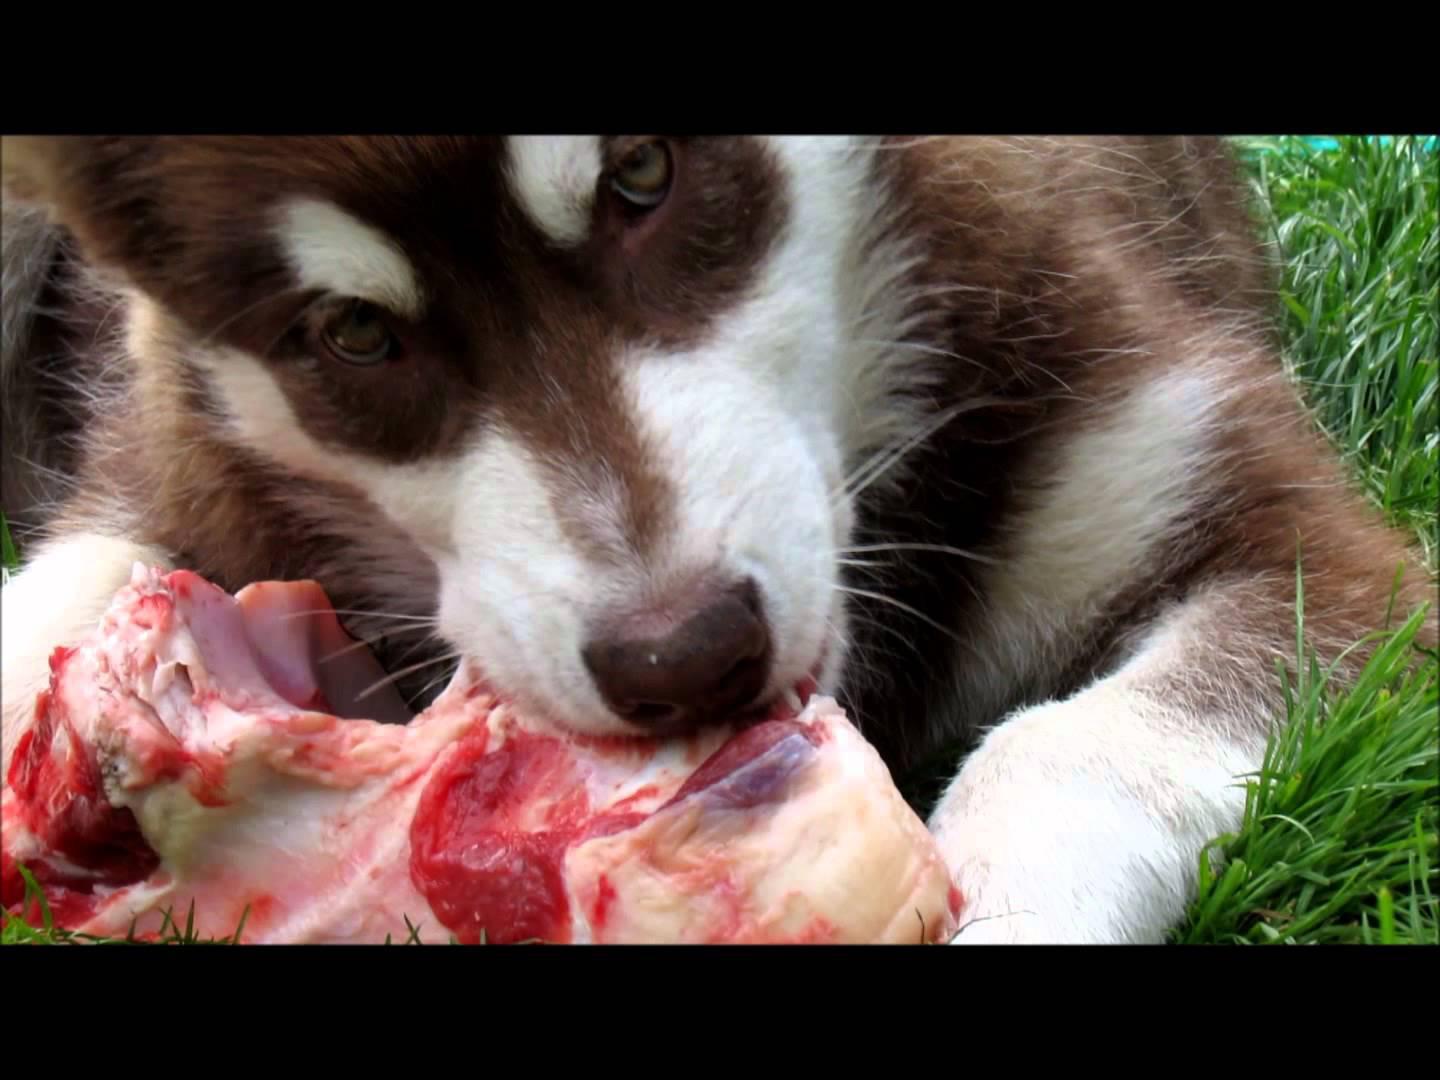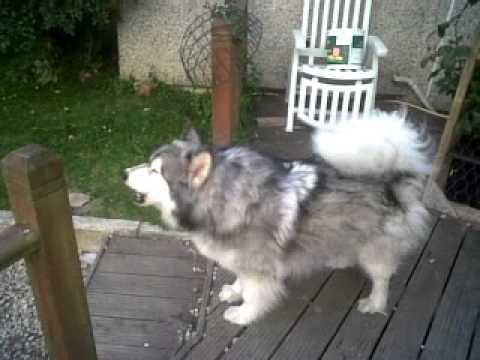The first image is the image on the left, the second image is the image on the right. For the images displayed, is the sentence "The husky is holding something in its mouth." factually correct? Answer yes or no. Yes. The first image is the image on the left, the second image is the image on the right. Assess this claim about the two images: "There are two dogs on grass.". Correct or not? Answer yes or no. No. 